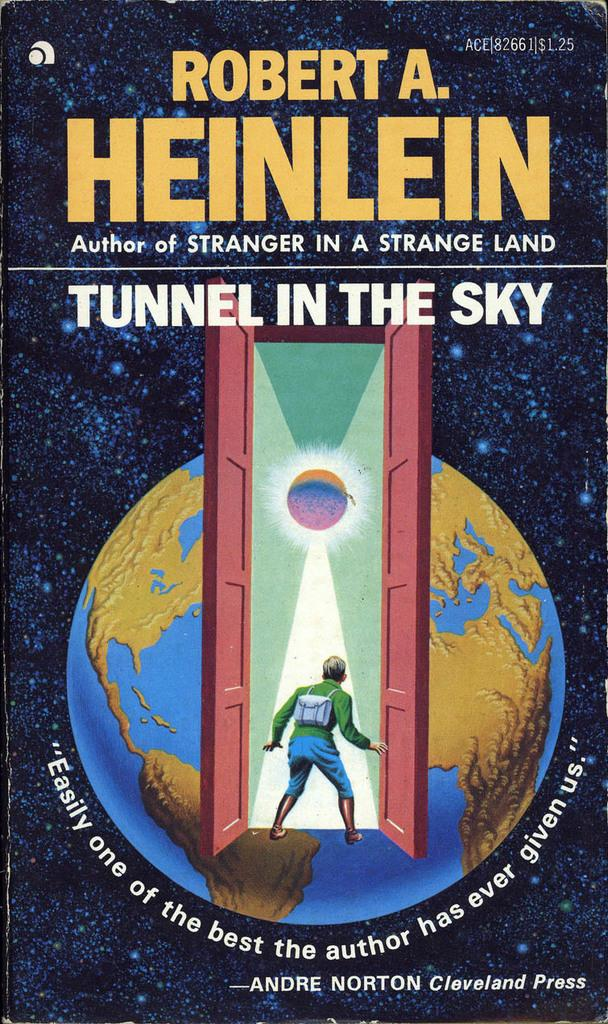<image>
Share a concise interpretation of the image provided. A book cover for "Tunnel in the Sky" shows a person in an open doorway and planet Earth. 